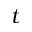Convert formula to latex. <formula><loc_0><loc_0><loc_500><loc_500>t</formula> 